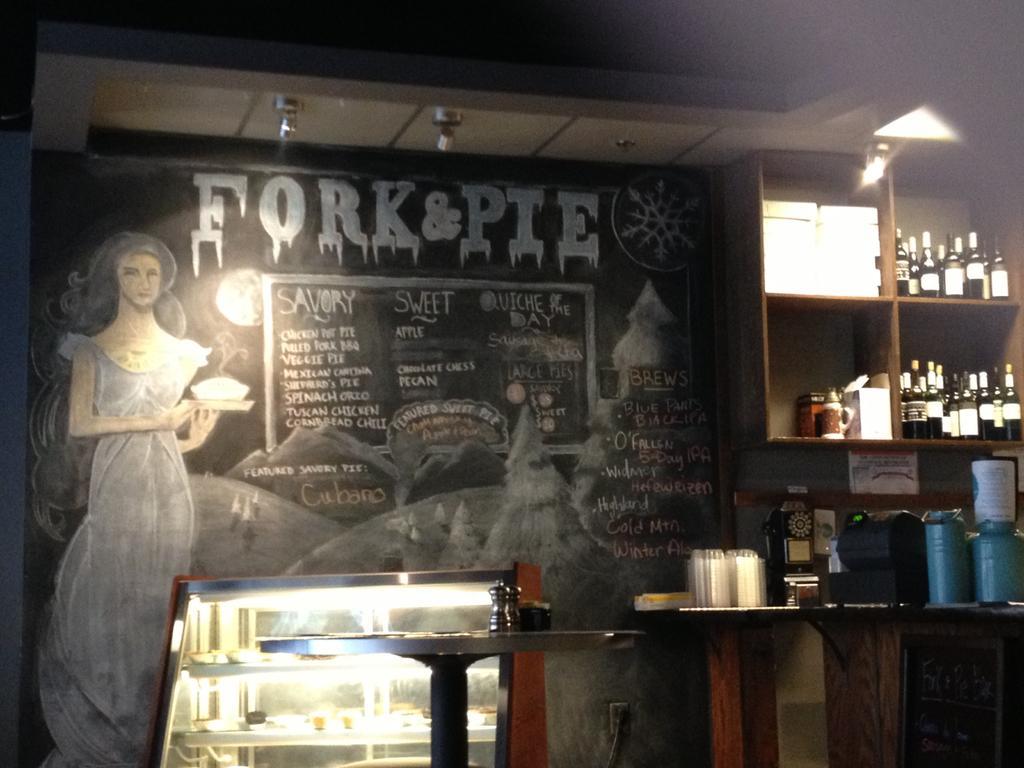In one or two sentences, can you explain what this image depicts? In this image we can see a board in which we can see the drawing of a woman holding a bowl with a plate, the hills, trees and some text on it. We can also see a roof with some ceiling lights. On the right side we can see a group of bottles and some containers placed in the shelves. We can also see a group of objects, containers and some devices on a table. In the foreground we can see some containers on a table. 